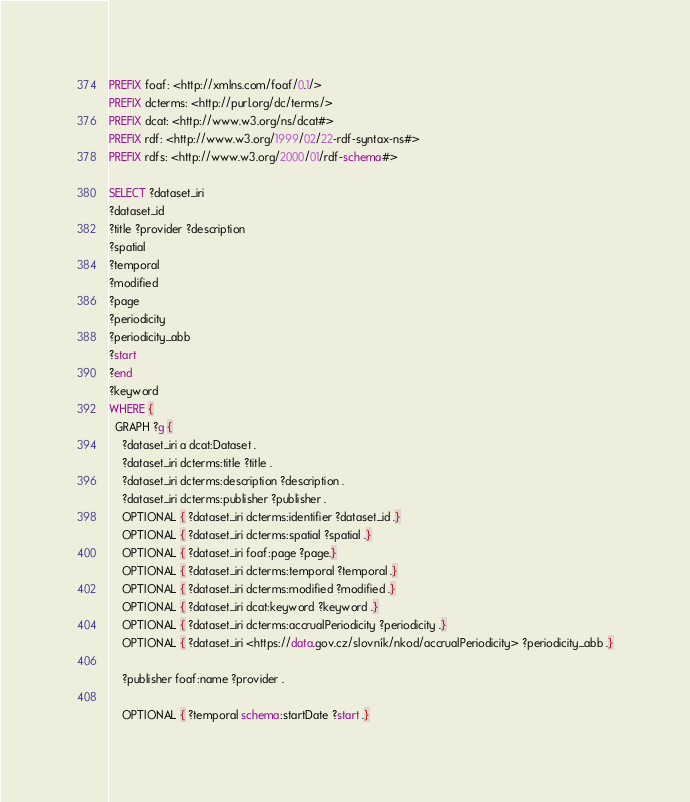<code> <loc_0><loc_0><loc_500><loc_500><_SQL_>PREFIX foaf: <http://xmlns.com/foaf/0.1/>
PREFIX dcterms: <http://purl.org/dc/terms/>
PREFIX dcat: <http://www.w3.org/ns/dcat#>
PREFIX rdf: <http://www.w3.org/1999/02/22-rdf-syntax-ns#>
PREFIX rdfs: <http://www.w3.org/2000/01/rdf-schema#>

SELECT ?dataset_iri
?dataset_id
?title ?provider ?description
?spatial
?temporal
?modified
?page
?periodicity
?periodicity_abb
?start
?end
?keyword
WHERE {
  GRAPH ?g {
    ?dataset_iri a dcat:Dataset .
    ?dataset_iri dcterms:title ?title .
    ?dataset_iri dcterms:description ?description .
    ?dataset_iri dcterms:publisher ?publisher .
    OPTIONAL { ?dataset_iri dcterms:identifier ?dataset_id .}
    OPTIONAL { ?dataset_iri dcterms:spatial ?spatial .}
    OPTIONAL { ?dataset_iri foaf:page ?page.}
    OPTIONAL { ?dataset_iri dcterms:temporal ?temporal .}
    OPTIONAL { ?dataset_iri dcterms:modified ?modified .}
    OPTIONAL { ?dataset_iri dcat:keyword ?keyword .}
    OPTIONAL { ?dataset_iri dcterms:accrualPeriodicity ?periodicity .}
    OPTIONAL { ?dataset_iri <https://data.gov.cz/slovník/nkod/accrualPeriodicity> ?periodicity_abb .}

    ?publisher foaf:name ?provider .

    OPTIONAL { ?temporal schema:startDate ?start .}</code> 